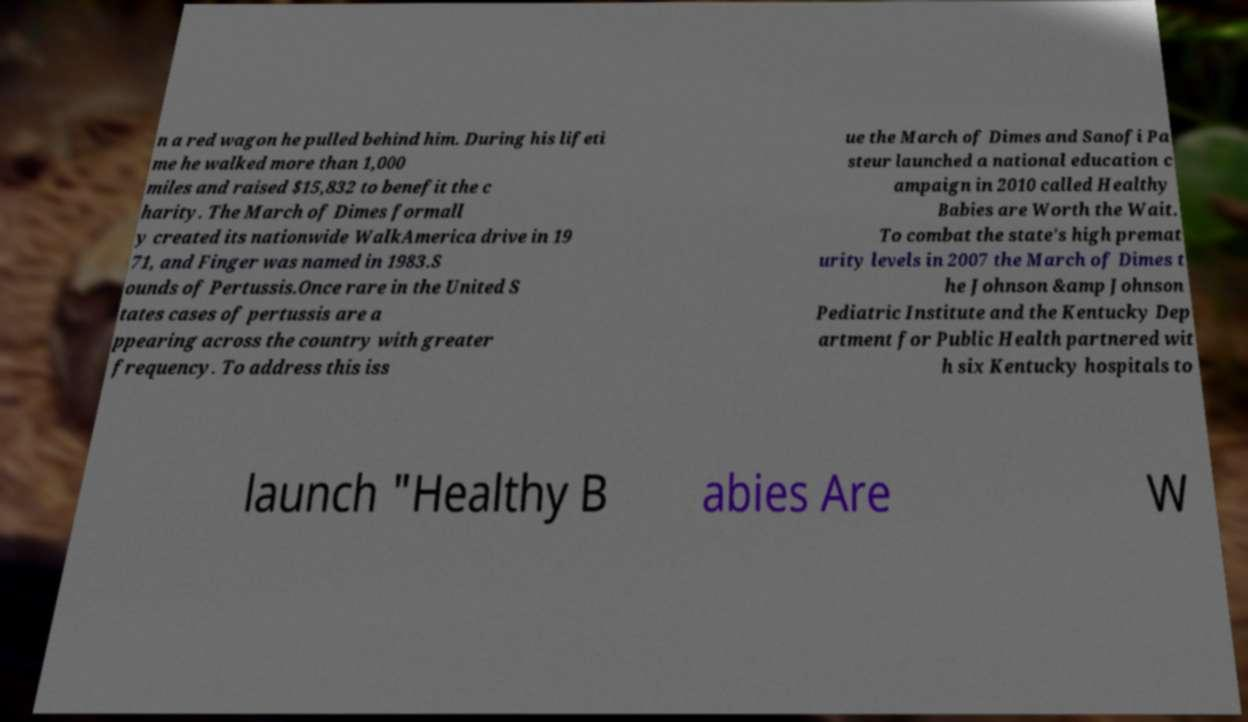There's text embedded in this image that I need extracted. Can you transcribe it verbatim? n a red wagon he pulled behind him. During his lifeti me he walked more than 1,000 miles and raised $15,832 to benefit the c harity. The March of Dimes formall y created its nationwide WalkAmerica drive in 19 71, and Finger was named in 1983.S ounds of Pertussis.Once rare in the United S tates cases of pertussis are a ppearing across the country with greater frequency. To address this iss ue the March of Dimes and Sanofi Pa steur launched a national education c ampaign in 2010 called Healthy Babies are Worth the Wait. To combat the state's high premat urity levels in 2007 the March of Dimes t he Johnson &amp Johnson Pediatric Institute and the Kentucky Dep artment for Public Health partnered wit h six Kentucky hospitals to launch "Healthy B abies Are W 